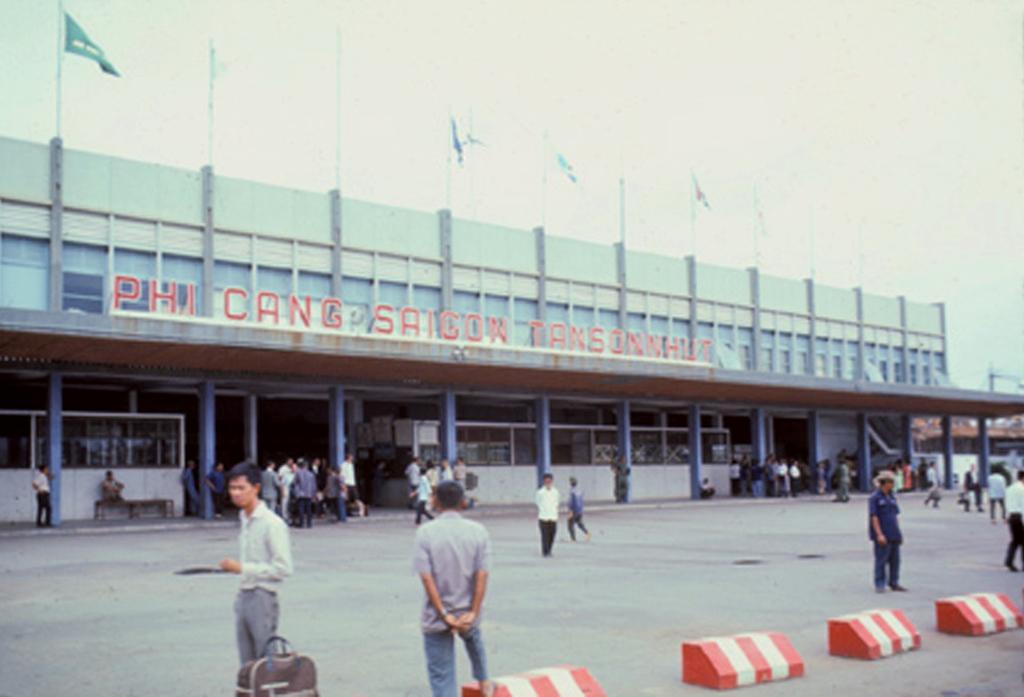Describe this image in one or two sentences. In this image there are group of persons standing and walking. In the front there are objects on the ground which are red and white in colour and there is a bag which is brown in colour. In the background there is a building and there is some text written on the building and on the top of the building there are flags and on the right side of the building there is a house. 